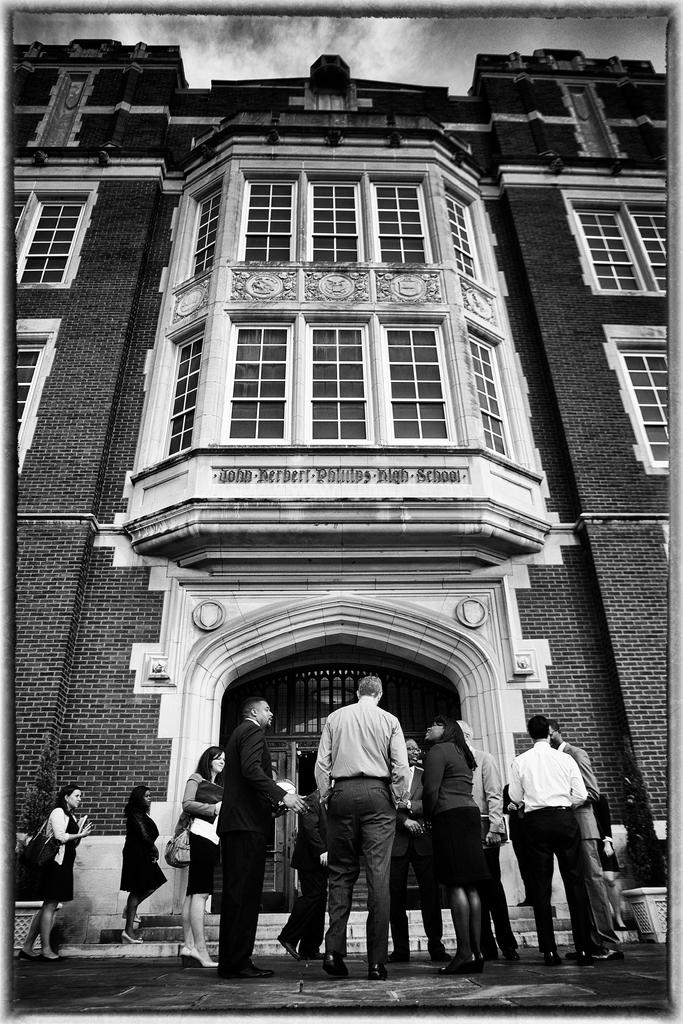What is the color scheme of the image? The image is black and white. What can be seen on the side path in the image? There are persons standing on the side path. What is visible in the background of the image? There is a building in the background. What is visible at the top of the image? The sky is visible at the top of the image. What can be observed in the sky? Clouds are present in the sky. What is the income of the fireman in the image? There is no fireman present in the image, so it is not possible to determine their income. What type of table is visible in the image? There is no table present in the image. 